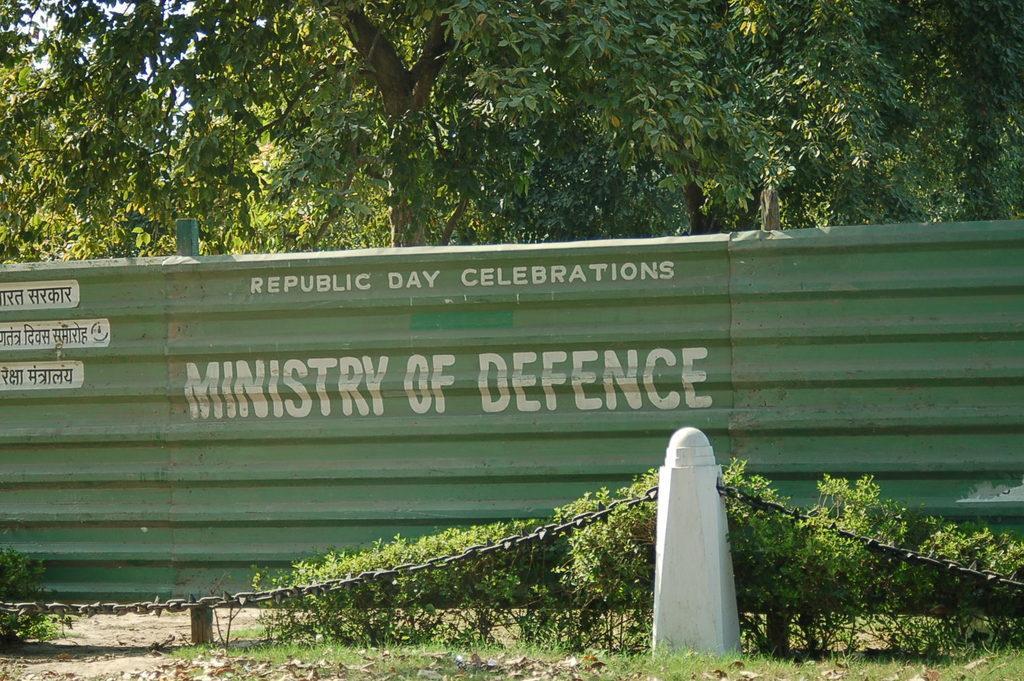Could you give a brief overview of what you see in this image? In this image we can see the fencing wall with the text. We can also see a barrier rod with the chain. We can see the plants, grass, dried leaves and also the trees. 